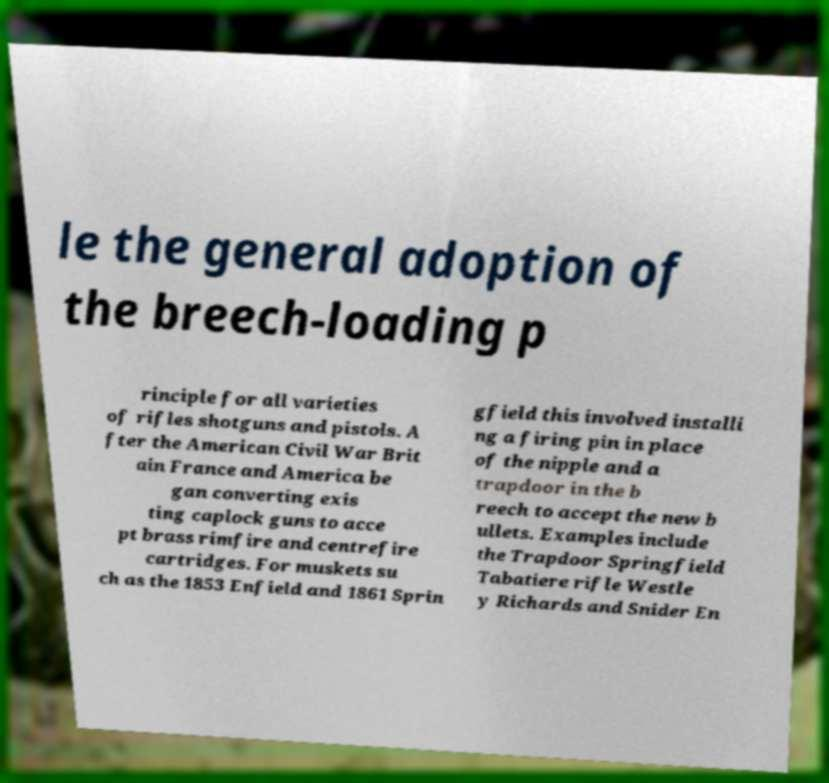Could you extract and type out the text from this image? le the general adoption of the breech-loading p rinciple for all varieties of rifles shotguns and pistols. A fter the American Civil War Brit ain France and America be gan converting exis ting caplock guns to acce pt brass rimfire and centrefire cartridges. For muskets su ch as the 1853 Enfield and 1861 Sprin gfield this involved installi ng a firing pin in place of the nipple and a trapdoor in the b reech to accept the new b ullets. Examples include the Trapdoor Springfield Tabatiere rifle Westle y Richards and Snider En 